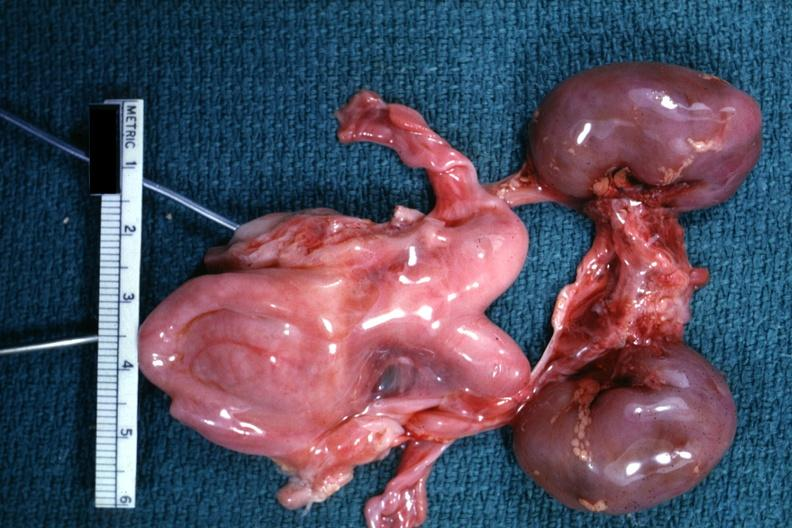s bicornate uterus present?
Answer the question using a single word or phrase. Yes 